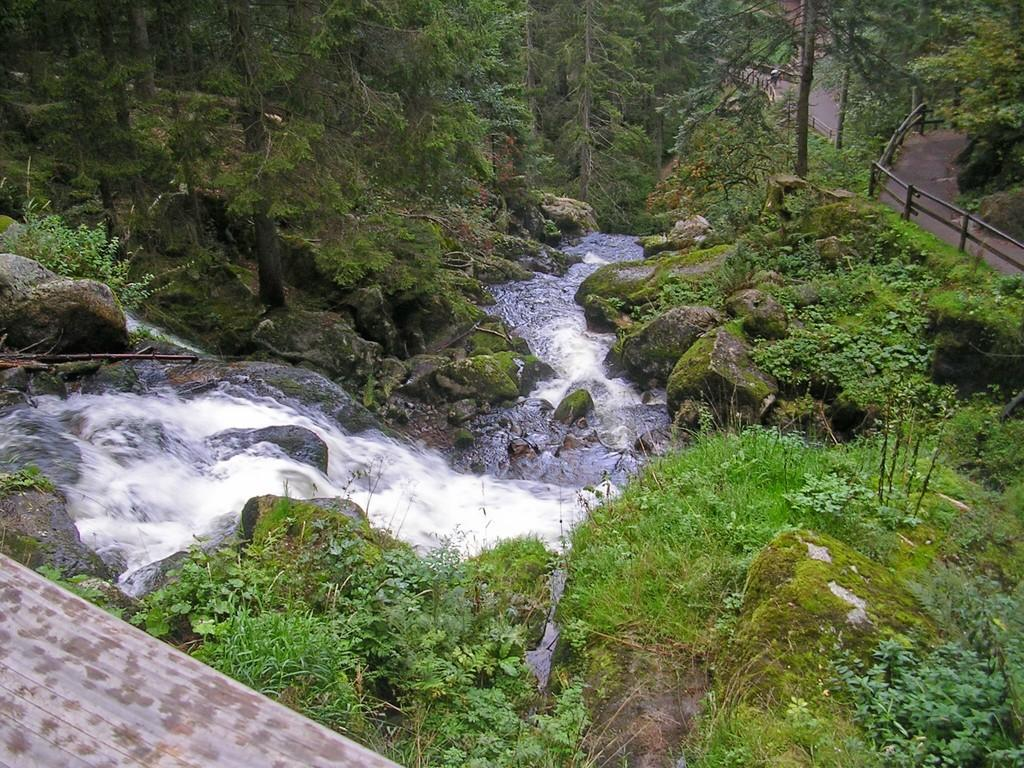What natural feature is the main subject of the image? There is a waterfall in the image. What can be seen on the ground near the waterfall? There are rocks and iron fencing poles on the ground in the image. What type of vegetation is present in the image? There are trees in the image, and the ground is covered with grass. How many chickens are participating in the competition near the waterfall? There are no chickens or competitions present in the image; it features a waterfall, rocks, iron fencing poles, trees, and grass-covered ground. 